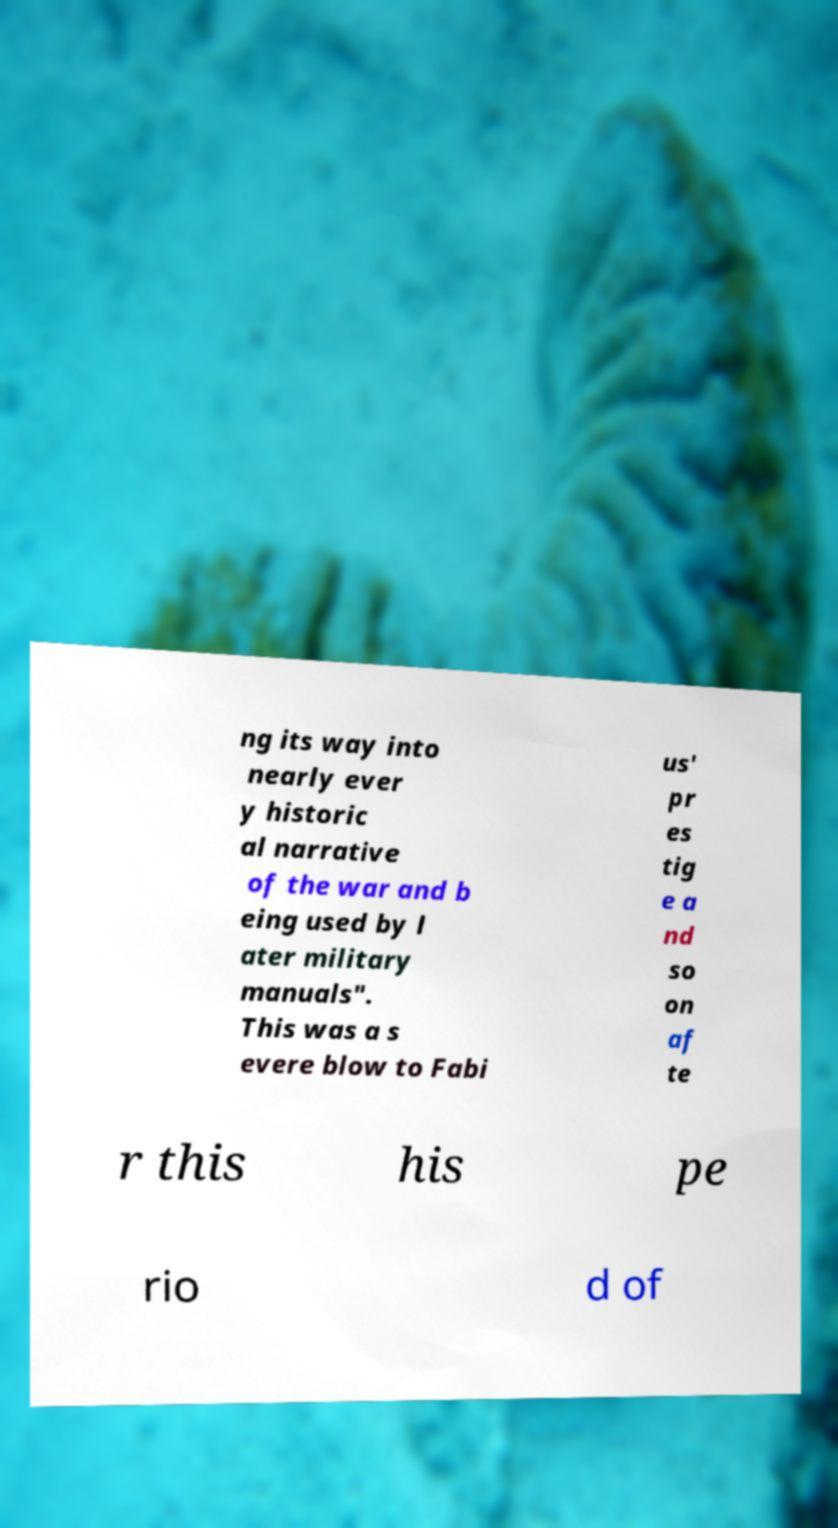There's text embedded in this image that I need extracted. Can you transcribe it verbatim? ng its way into nearly ever y historic al narrative of the war and b eing used by l ater military manuals". This was a s evere blow to Fabi us' pr es tig e a nd so on af te r this his pe rio d of 